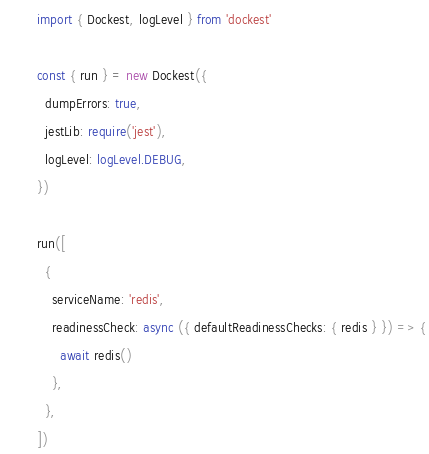Convert code to text. <code><loc_0><loc_0><loc_500><loc_500><_TypeScript_>import { Dockest, logLevel } from 'dockest'

const { run } = new Dockest({
  dumpErrors: true,
  jestLib: require('jest'),
  logLevel: logLevel.DEBUG,
})

run([
  {
    serviceName: 'redis',
    readinessCheck: async ({ defaultReadinessChecks: { redis } }) => {
      await redis()
    },
  },
])
</code> 